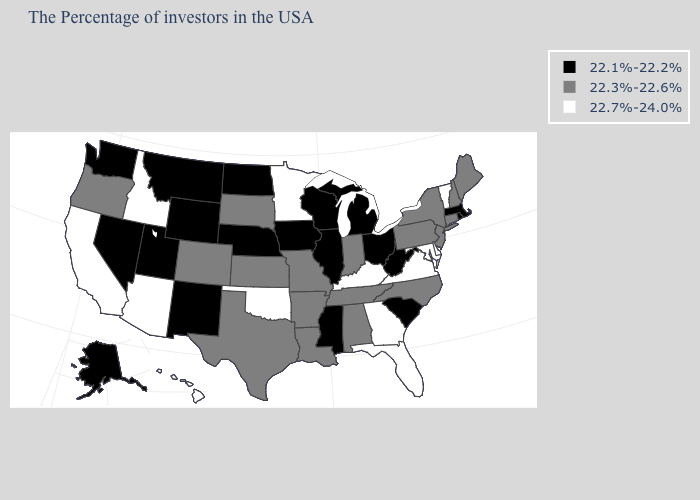What is the value of Colorado?
Answer briefly. 22.3%-22.6%. What is the value of Indiana?
Concise answer only. 22.3%-22.6%. What is the value of Virginia?
Be succinct. 22.7%-24.0%. Name the states that have a value in the range 22.1%-22.2%?
Give a very brief answer. Massachusetts, Rhode Island, South Carolina, West Virginia, Ohio, Michigan, Wisconsin, Illinois, Mississippi, Iowa, Nebraska, North Dakota, Wyoming, New Mexico, Utah, Montana, Nevada, Washington, Alaska. Among the states that border Pennsylvania , does Maryland have the lowest value?
Give a very brief answer. No. Which states have the lowest value in the Northeast?
Give a very brief answer. Massachusetts, Rhode Island. Does South Dakota have the lowest value in the MidWest?
Concise answer only. No. Which states have the highest value in the USA?
Give a very brief answer. Vermont, Delaware, Maryland, Virginia, Florida, Georgia, Kentucky, Minnesota, Oklahoma, Arizona, Idaho, California, Hawaii. Does Maryland have a higher value than Kentucky?
Be succinct. No. Name the states that have a value in the range 22.1%-22.2%?
Give a very brief answer. Massachusetts, Rhode Island, South Carolina, West Virginia, Ohio, Michigan, Wisconsin, Illinois, Mississippi, Iowa, Nebraska, North Dakota, Wyoming, New Mexico, Utah, Montana, Nevada, Washington, Alaska. What is the value of Tennessee?
Quick response, please. 22.3%-22.6%. How many symbols are there in the legend?
Keep it brief. 3. Name the states that have a value in the range 22.1%-22.2%?
Concise answer only. Massachusetts, Rhode Island, South Carolina, West Virginia, Ohio, Michigan, Wisconsin, Illinois, Mississippi, Iowa, Nebraska, North Dakota, Wyoming, New Mexico, Utah, Montana, Nevada, Washington, Alaska. What is the lowest value in the USA?
Short answer required. 22.1%-22.2%. Name the states that have a value in the range 22.3%-22.6%?
Keep it brief. Maine, New Hampshire, Connecticut, New York, New Jersey, Pennsylvania, North Carolina, Indiana, Alabama, Tennessee, Louisiana, Missouri, Arkansas, Kansas, Texas, South Dakota, Colorado, Oregon. 